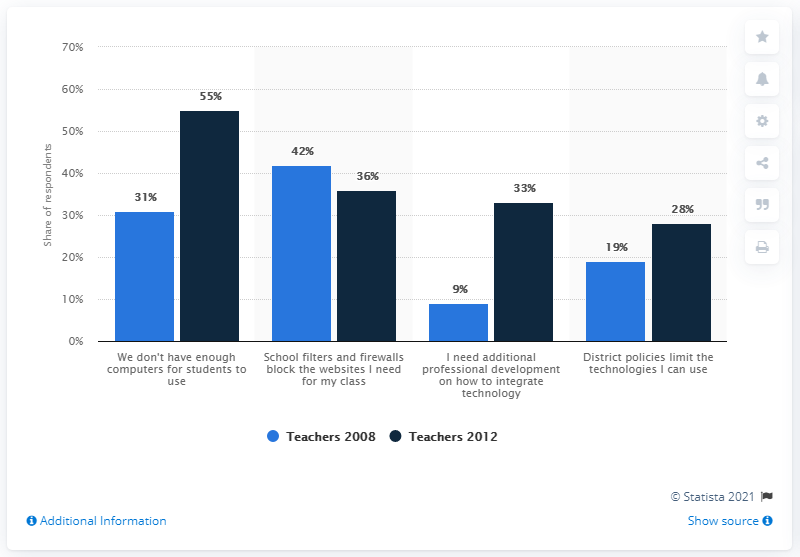Mention a couple of crucial points in this snapshot. In a survey conducted in 2012, 55% of respondents reported that the lack of computers for students was the most common obstacle faced by classroom teachers in the United States. 